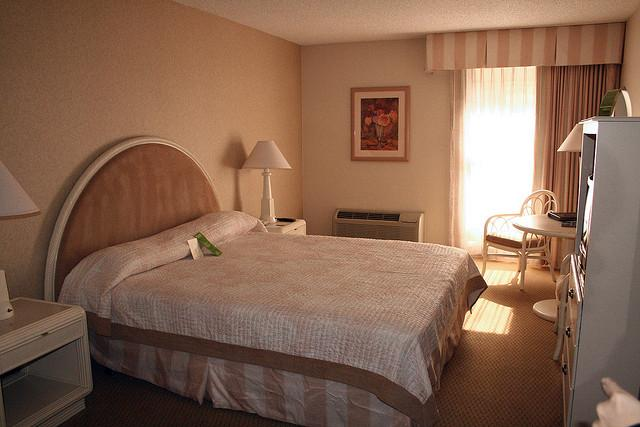What type of establishment is known to put notecards on beds like this?

Choices:
A) hotels
B) arenas
C) lobbies
D) parks hotels 